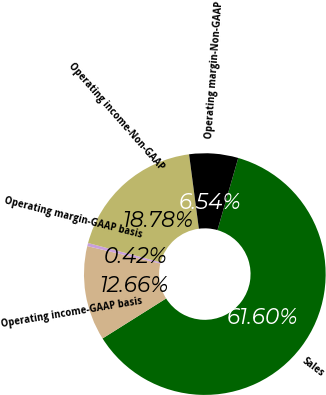Convert chart to OTSL. <chart><loc_0><loc_0><loc_500><loc_500><pie_chart><fcel>Sales<fcel>Operating income-GAAP basis<fcel>Operating margin-GAAP basis<fcel>Operating income-Non-GAAP<fcel>Operating margin-Non-GAAP<nl><fcel>61.6%<fcel>12.66%<fcel>0.42%<fcel>18.78%<fcel>6.54%<nl></chart> 